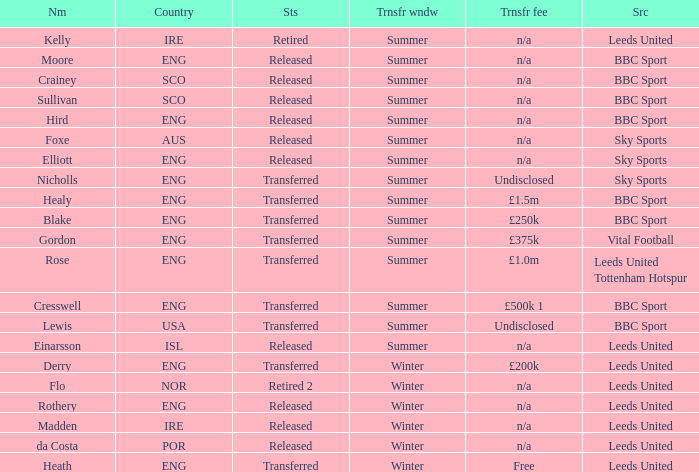What is the current status of the person named Nicholls? Transferred. 